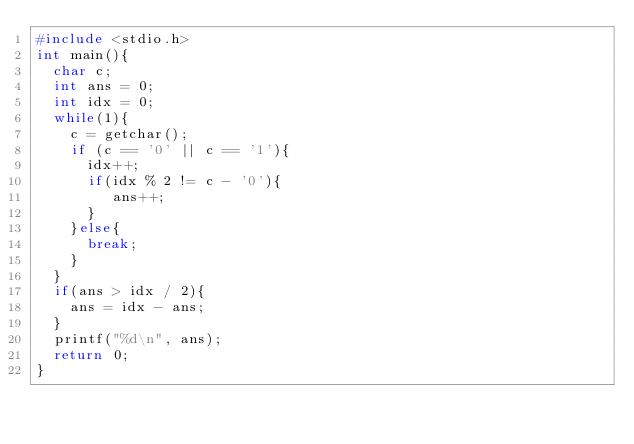Convert code to text. <code><loc_0><loc_0><loc_500><loc_500><_C_>#include <stdio.h>
int main(){
  char c;
  int ans = 0;
  int idx = 0;
  while(1){
    c = getchar();
    if (c == '0' || c == '1'){
      idx++;
      if(idx % 2 != c - '0'){
         ans++;
      }
    }else{
      break;
    }
  }
  if(ans > idx / 2){
    ans = idx - ans;
  }
  printf("%d\n", ans);
  return 0;
}</code> 